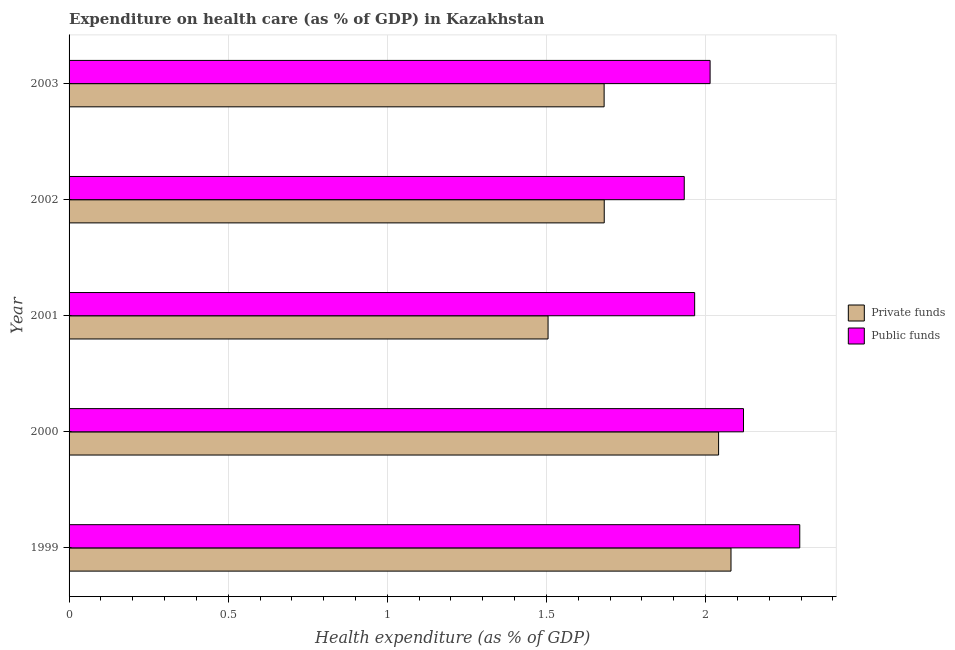How many groups of bars are there?
Your response must be concise. 5. Are the number of bars on each tick of the Y-axis equal?
Your answer should be very brief. Yes. How many bars are there on the 1st tick from the top?
Your response must be concise. 2. How many bars are there on the 4th tick from the bottom?
Keep it short and to the point. 2. What is the amount of public funds spent in healthcare in 2003?
Your answer should be very brief. 2.01. Across all years, what is the maximum amount of public funds spent in healthcare?
Provide a succinct answer. 2.3. Across all years, what is the minimum amount of public funds spent in healthcare?
Your answer should be very brief. 1.93. In which year was the amount of private funds spent in healthcare maximum?
Ensure brevity in your answer.  1999. What is the total amount of public funds spent in healthcare in the graph?
Keep it short and to the point. 10.33. What is the difference between the amount of private funds spent in healthcare in 2000 and that in 2002?
Keep it short and to the point. 0.36. What is the difference between the amount of public funds spent in healthcare in 2002 and the amount of private funds spent in healthcare in 2001?
Your answer should be very brief. 0.43. What is the average amount of private funds spent in healthcare per year?
Provide a short and direct response. 1.8. In the year 2003, what is the difference between the amount of private funds spent in healthcare and amount of public funds spent in healthcare?
Your response must be concise. -0.33. What is the ratio of the amount of private funds spent in healthcare in 2001 to that in 2003?
Keep it short and to the point. 0.9. Is the amount of public funds spent in healthcare in 2002 less than that in 2003?
Offer a terse response. Yes. What is the difference between the highest and the second highest amount of private funds spent in healthcare?
Keep it short and to the point. 0.04. What is the difference between the highest and the lowest amount of private funds spent in healthcare?
Your answer should be compact. 0.57. What does the 1st bar from the top in 2000 represents?
Your answer should be compact. Public funds. What does the 1st bar from the bottom in 2003 represents?
Provide a succinct answer. Private funds. Does the graph contain any zero values?
Provide a succinct answer. No. Does the graph contain grids?
Provide a short and direct response. Yes. Where does the legend appear in the graph?
Offer a terse response. Center right. How are the legend labels stacked?
Make the answer very short. Vertical. What is the title of the graph?
Keep it short and to the point. Expenditure on health care (as % of GDP) in Kazakhstan. Does "Under five" appear as one of the legend labels in the graph?
Make the answer very short. No. What is the label or title of the X-axis?
Keep it short and to the point. Health expenditure (as % of GDP). What is the label or title of the Y-axis?
Your answer should be compact. Year. What is the Health expenditure (as % of GDP) in Private funds in 1999?
Provide a short and direct response. 2.08. What is the Health expenditure (as % of GDP) of Public funds in 1999?
Keep it short and to the point. 2.3. What is the Health expenditure (as % of GDP) in Private funds in 2000?
Your answer should be very brief. 2.04. What is the Health expenditure (as % of GDP) in Public funds in 2000?
Offer a very short reply. 2.12. What is the Health expenditure (as % of GDP) of Private funds in 2001?
Provide a short and direct response. 1.51. What is the Health expenditure (as % of GDP) in Public funds in 2001?
Your answer should be compact. 1.97. What is the Health expenditure (as % of GDP) of Private funds in 2002?
Ensure brevity in your answer.  1.68. What is the Health expenditure (as % of GDP) in Public funds in 2002?
Provide a short and direct response. 1.93. What is the Health expenditure (as % of GDP) of Private funds in 2003?
Your response must be concise. 1.68. What is the Health expenditure (as % of GDP) of Public funds in 2003?
Ensure brevity in your answer.  2.01. Across all years, what is the maximum Health expenditure (as % of GDP) in Private funds?
Provide a succinct answer. 2.08. Across all years, what is the maximum Health expenditure (as % of GDP) of Public funds?
Your answer should be compact. 2.3. Across all years, what is the minimum Health expenditure (as % of GDP) in Private funds?
Your answer should be compact. 1.51. Across all years, what is the minimum Health expenditure (as % of GDP) of Public funds?
Provide a succinct answer. 1.93. What is the total Health expenditure (as % of GDP) of Private funds in the graph?
Make the answer very short. 8.99. What is the total Health expenditure (as % of GDP) of Public funds in the graph?
Your answer should be very brief. 10.33. What is the difference between the Health expenditure (as % of GDP) of Private funds in 1999 and that in 2000?
Provide a short and direct response. 0.04. What is the difference between the Health expenditure (as % of GDP) in Public funds in 1999 and that in 2000?
Make the answer very short. 0.18. What is the difference between the Health expenditure (as % of GDP) in Private funds in 1999 and that in 2001?
Provide a succinct answer. 0.57. What is the difference between the Health expenditure (as % of GDP) in Public funds in 1999 and that in 2001?
Your answer should be very brief. 0.33. What is the difference between the Health expenditure (as % of GDP) of Private funds in 1999 and that in 2002?
Your response must be concise. 0.4. What is the difference between the Health expenditure (as % of GDP) of Public funds in 1999 and that in 2002?
Keep it short and to the point. 0.36. What is the difference between the Health expenditure (as % of GDP) in Private funds in 1999 and that in 2003?
Offer a terse response. 0.4. What is the difference between the Health expenditure (as % of GDP) of Public funds in 1999 and that in 2003?
Provide a succinct answer. 0.28. What is the difference between the Health expenditure (as % of GDP) in Private funds in 2000 and that in 2001?
Keep it short and to the point. 0.54. What is the difference between the Health expenditure (as % of GDP) of Public funds in 2000 and that in 2001?
Your response must be concise. 0.15. What is the difference between the Health expenditure (as % of GDP) in Private funds in 2000 and that in 2002?
Your answer should be compact. 0.36. What is the difference between the Health expenditure (as % of GDP) of Public funds in 2000 and that in 2002?
Ensure brevity in your answer.  0.19. What is the difference between the Health expenditure (as % of GDP) in Private funds in 2000 and that in 2003?
Provide a succinct answer. 0.36. What is the difference between the Health expenditure (as % of GDP) in Public funds in 2000 and that in 2003?
Offer a very short reply. 0.1. What is the difference between the Health expenditure (as % of GDP) of Private funds in 2001 and that in 2002?
Your answer should be compact. -0.18. What is the difference between the Health expenditure (as % of GDP) in Public funds in 2001 and that in 2002?
Your answer should be compact. 0.03. What is the difference between the Health expenditure (as % of GDP) of Private funds in 2001 and that in 2003?
Ensure brevity in your answer.  -0.18. What is the difference between the Health expenditure (as % of GDP) in Public funds in 2001 and that in 2003?
Ensure brevity in your answer.  -0.05. What is the difference between the Health expenditure (as % of GDP) in Private funds in 2002 and that in 2003?
Offer a terse response. 0. What is the difference between the Health expenditure (as % of GDP) of Public funds in 2002 and that in 2003?
Provide a succinct answer. -0.08. What is the difference between the Health expenditure (as % of GDP) in Private funds in 1999 and the Health expenditure (as % of GDP) in Public funds in 2000?
Ensure brevity in your answer.  -0.04. What is the difference between the Health expenditure (as % of GDP) of Private funds in 1999 and the Health expenditure (as % of GDP) of Public funds in 2001?
Offer a terse response. 0.11. What is the difference between the Health expenditure (as % of GDP) of Private funds in 1999 and the Health expenditure (as % of GDP) of Public funds in 2002?
Make the answer very short. 0.15. What is the difference between the Health expenditure (as % of GDP) of Private funds in 1999 and the Health expenditure (as % of GDP) of Public funds in 2003?
Provide a succinct answer. 0.07. What is the difference between the Health expenditure (as % of GDP) in Private funds in 2000 and the Health expenditure (as % of GDP) in Public funds in 2001?
Keep it short and to the point. 0.08. What is the difference between the Health expenditure (as % of GDP) in Private funds in 2000 and the Health expenditure (as % of GDP) in Public funds in 2002?
Offer a terse response. 0.11. What is the difference between the Health expenditure (as % of GDP) in Private funds in 2000 and the Health expenditure (as % of GDP) in Public funds in 2003?
Provide a succinct answer. 0.03. What is the difference between the Health expenditure (as % of GDP) of Private funds in 2001 and the Health expenditure (as % of GDP) of Public funds in 2002?
Ensure brevity in your answer.  -0.43. What is the difference between the Health expenditure (as % of GDP) in Private funds in 2001 and the Health expenditure (as % of GDP) in Public funds in 2003?
Ensure brevity in your answer.  -0.51. What is the difference between the Health expenditure (as % of GDP) of Private funds in 2002 and the Health expenditure (as % of GDP) of Public funds in 2003?
Provide a short and direct response. -0.33. What is the average Health expenditure (as % of GDP) of Private funds per year?
Give a very brief answer. 1.8. What is the average Health expenditure (as % of GDP) of Public funds per year?
Provide a short and direct response. 2.07. In the year 1999, what is the difference between the Health expenditure (as % of GDP) of Private funds and Health expenditure (as % of GDP) of Public funds?
Ensure brevity in your answer.  -0.22. In the year 2000, what is the difference between the Health expenditure (as % of GDP) in Private funds and Health expenditure (as % of GDP) in Public funds?
Your response must be concise. -0.08. In the year 2001, what is the difference between the Health expenditure (as % of GDP) of Private funds and Health expenditure (as % of GDP) of Public funds?
Your answer should be very brief. -0.46. In the year 2002, what is the difference between the Health expenditure (as % of GDP) in Private funds and Health expenditure (as % of GDP) in Public funds?
Provide a succinct answer. -0.25. In the year 2003, what is the difference between the Health expenditure (as % of GDP) in Private funds and Health expenditure (as % of GDP) in Public funds?
Give a very brief answer. -0.33. What is the ratio of the Health expenditure (as % of GDP) of Private funds in 1999 to that in 2000?
Ensure brevity in your answer.  1.02. What is the ratio of the Health expenditure (as % of GDP) in Public funds in 1999 to that in 2000?
Provide a succinct answer. 1.08. What is the ratio of the Health expenditure (as % of GDP) in Private funds in 1999 to that in 2001?
Offer a very short reply. 1.38. What is the ratio of the Health expenditure (as % of GDP) in Public funds in 1999 to that in 2001?
Your response must be concise. 1.17. What is the ratio of the Health expenditure (as % of GDP) in Private funds in 1999 to that in 2002?
Make the answer very short. 1.24. What is the ratio of the Health expenditure (as % of GDP) in Public funds in 1999 to that in 2002?
Your answer should be very brief. 1.19. What is the ratio of the Health expenditure (as % of GDP) in Private funds in 1999 to that in 2003?
Your answer should be very brief. 1.24. What is the ratio of the Health expenditure (as % of GDP) of Public funds in 1999 to that in 2003?
Offer a terse response. 1.14. What is the ratio of the Health expenditure (as % of GDP) in Private funds in 2000 to that in 2001?
Keep it short and to the point. 1.36. What is the ratio of the Health expenditure (as % of GDP) in Public funds in 2000 to that in 2001?
Ensure brevity in your answer.  1.08. What is the ratio of the Health expenditure (as % of GDP) in Private funds in 2000 to that in 2002?
Your answer should be compact. 1.21. What is the ratio of the Health expenditure (as % of GDP) of Public funds in 2000 to that in 2002?
Your answer should be compact. 1.1. What is the ratio of the Health expenditure (as % of GDP) in Private funds in 2000 to that in 2003?
Keep it short and to the point. 1.21. What is the ratio of the Health expenditure (as % of GDP) of Public funds in 2000 to that in 2003?
Provide a succinct answer. 1.05. What is the ratio of the Health expenditure (as % of GDP) of Private funds in 2001 to that in 2002?
Make the answer very short. 0.9. What is the ratio of the Health expenditure (as % of GDP) of Public funds in 2001 to that in 2002?
Offer a very short reply. 1.02. What is the ratio of the Health expenditure (as % of GDP) in Private funds in 2001 to that in 2003?
Your response must be concise. 0.9. What is the ratio of the Health expenditure (as % of GDP) in Public funds in 2001 to that in 2003?
Make the answer very short. 0.98. What is the ratio of the Health expenditure (as % of GDP) in Public funds in 2002 to that in 2003?
Provide a succinct answer. 0.96. What is the difference between the highest and the second highest Health expenditure (as % of GDP) in Private funds?
Provide a succinct answer. 0.04. What is the difference between the highest and the second highest Health expenditure (as % of GDP) in Public funds?
Give a very brief answer. 0.18. What is the difference between the highest and the lowest Health expenditure (as % of GDP) in Private funds?
Keep it short and to the point. 0.57. What is the difference between the highest and the lowest Health expenditure (as % of GDP) in Public funds?
Provide a succinct answer. 0.36. 